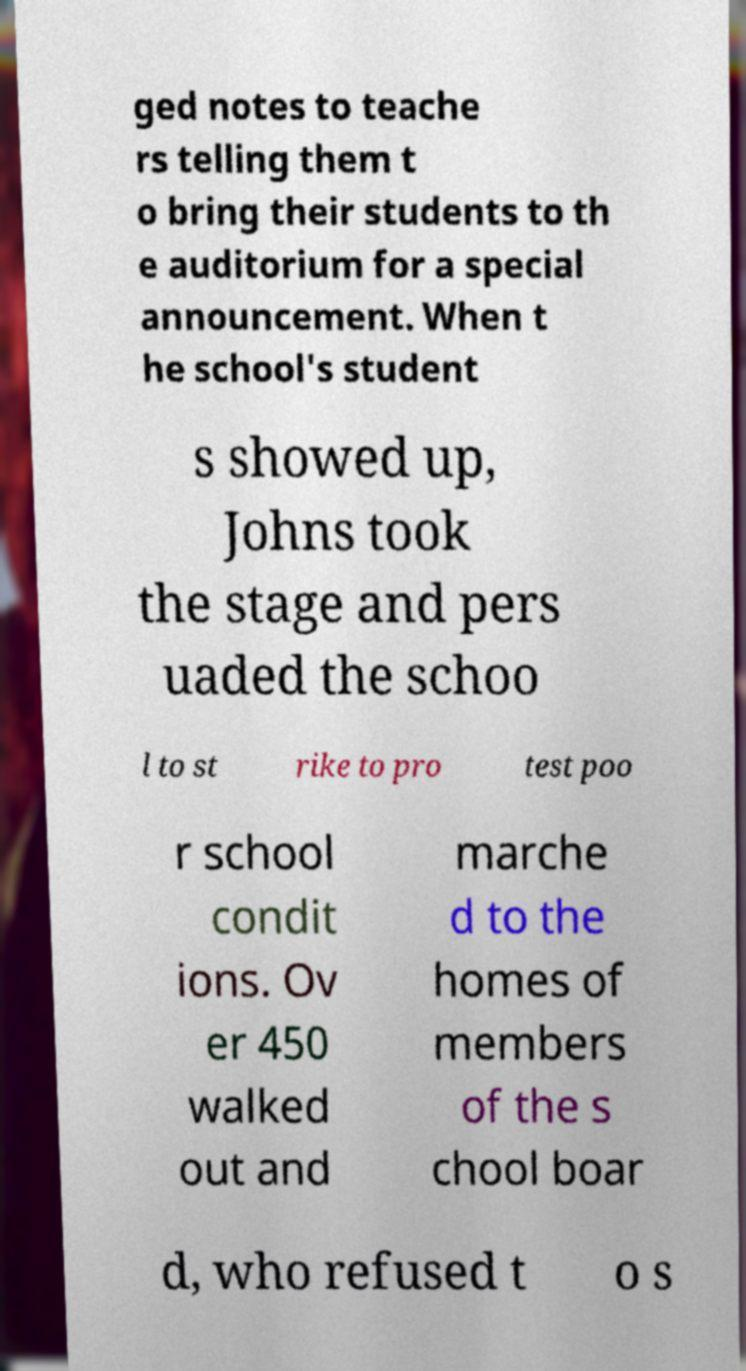There's text embedded in this image that I need extracted. Can you transcribe it verbatim? ged notes to teache rs telling them t o bring their students to th e auditorium for a special announcement. When t he school's student s showed up, Johns took the stage and pers uaded the schoo l to st rike to pro test poo r school condit ions. Ov er 450 walked out and marche d to the homes of members of the s chool boar d, who refused t o s 